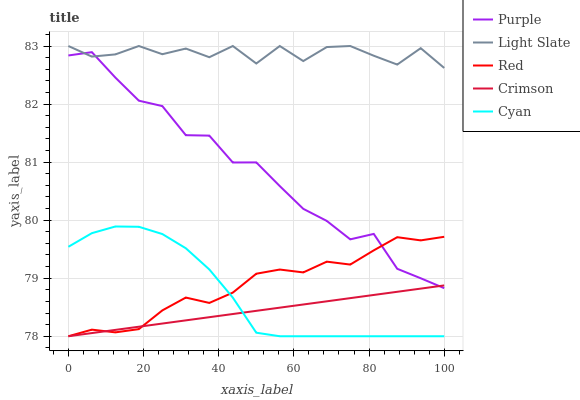Does Crimson have the minimum area under the curve?
Answer yes or no. Yes. Does Light Slate have the maximum area under the curve?
Answer yes or no. Yes. Does Light Slate have the minimum area under the curve?
Answer yes or no. No. Does Crimson have the maximum area under the curve?
Answer yes or no. No. Is Crimson the smoothest?
Answer yes or no. Yes. Is Light Slate the roughest?
Answer yes or no. Yes. Is Light Slate the smoothest?
Answer yes or no. No. Is Crimson the roughest?
Answer yes or no. No. Does Crimson have the lowest value?
Answer yes or no. Yes. Does Light Slate have the lowest value?
Answer yes or no. No. Does Light Slate have the highest value?
Answer yes or no. Yes. Does Crimson have the highest value?
Answer yes or no. No. Is Cyan less than Light Slate?
Answer yes or no. Yes. Is Light Slate greater than Cyan?
Answer yes or no. Yes. Does Crimson intersect Cyan?
Answer yes or no. Yes. Is Crimson less than Cyan?
Answer yes or no. No. Is Crimson greater than Cyan?
Answer yes or no. No. Does Cyan intersect Light Slate?
Answer yes or no. No. 